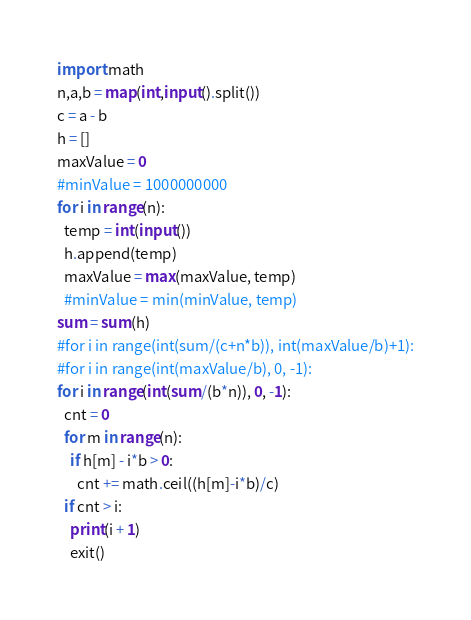<code> <loc_0><loc_0><loc_500><loc_500><_Python_>import math
n,a,b = map(int,input().split())
c = a - b
h = []
maxValue = 0
#minValue = 1000000000
for i in range(n):
  temp = int(input())
  h.append(temp)
  maxValue = max(maxValue, temp)
  #minValue = min(minValue, temp)
sum = sum(h)
#for i in range(int(sum/(c+n*b)), int(maxValue/b)+1):
#for i in range(int(maxValue/b), 0, -1):
for i in range(int(sum/(b*n)), 0, -1):
  cnt = 0
  for m in range(n):
    if h[m] - i*b > 0:
      cnt += math.ceil((h[m]-i*b)/c)
  if cnt > i:
    print(i + 1)
    exit()</code> 